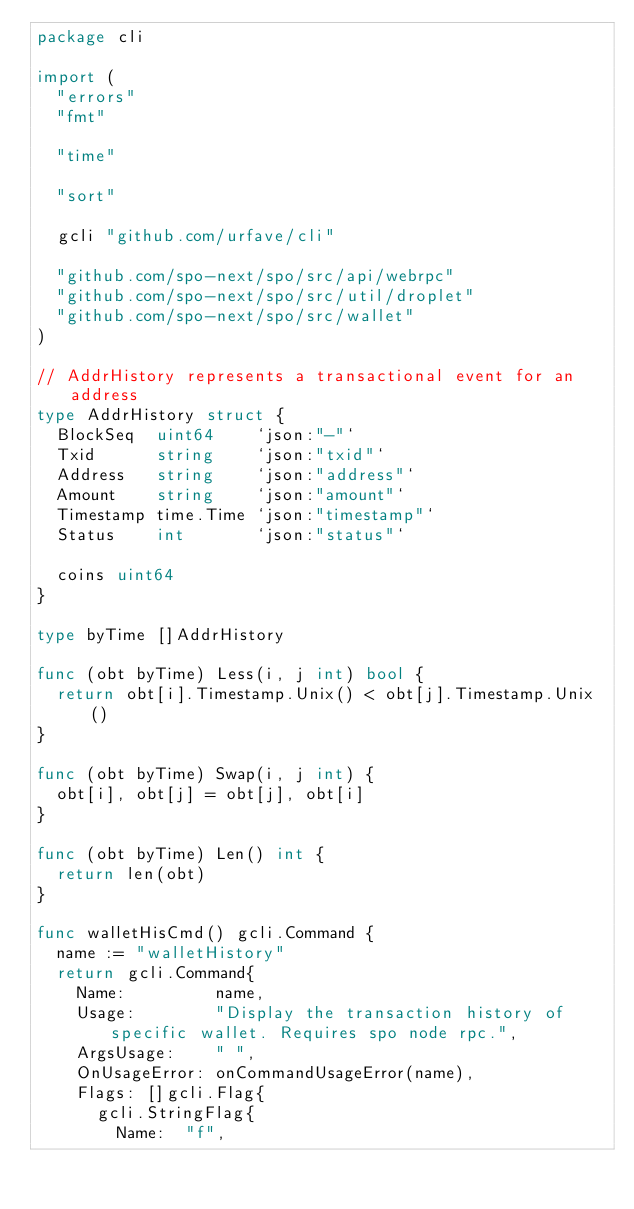<code> <loc_0><loc_0><loc_500><loc_500><_Go_>package cli

import (
	"errors"
	"fmt"

	"time"

	"sort"

	gcli "github.com/urfave/cli"

	"github.com/spo-next/spo/src/api/webrpc"
	"github.com/spo-next/spo/src/util/droplet"
	"github.com/spo-next/spo/src/wallet"
)

// AddrHistory represents a transactional event for an address
type AddrHistory struct {
	BlockSeq  uint64    `json:"-"`
	Txid      string    `json:"txid"`
	Address   string    `json:"address"`
	Amount    string    `json:"amount"`
	Timestamp time.Time `json:"timestamp"`
	Status    int       `json:"status"`

	coins uint64
}

type byTime []AddrHistory

func (obt byTime) Less(i, j int) bool {
	return obt[i].Timestamp.Unix() < obt[j].Timestamp.Unix()
}

func (obt byTime) Swap(i, j int) {
	obt[i], obt[j] = obt[j], obt[i]
}

func (obt byTime) Len() int {
	return len(obt)
}

func walletHisCmd() gcli.Command {
	name := "walletHistory"
	return gcli.Command{
		Name:         name,
		Usage:        "Display the transaction history of specific wallet. Requires spo node rpc.",
		ArgsUsage:    " ",
		OnUsageError: onCommandUsageError(name),
		Flags: []gcli.Flag{
			gcli.StringFlag{
				Name:  "f",</code> 